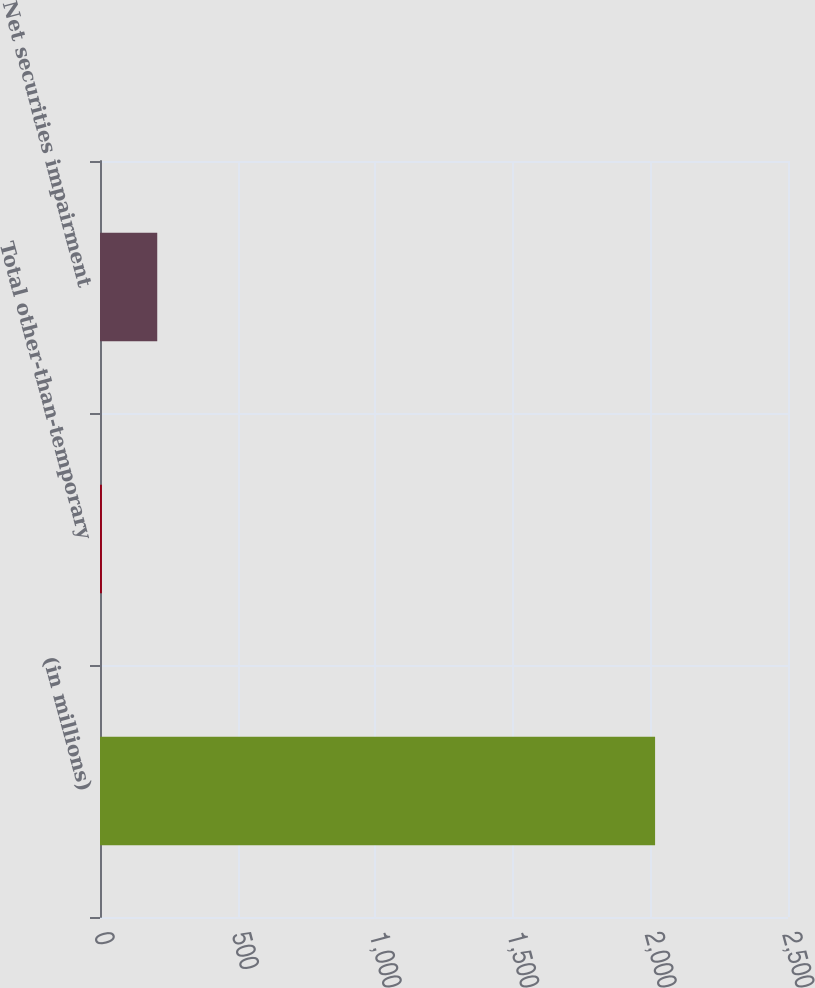<chart> <loc_0><loc_0><loc_500><loc_500><bar_chart><fcel>(in millions)<fcel>Total other-than-temporary<fcel>Net securities impairment<nl><fcel>2017<fcel>7<fcel>208<nl></chart> 